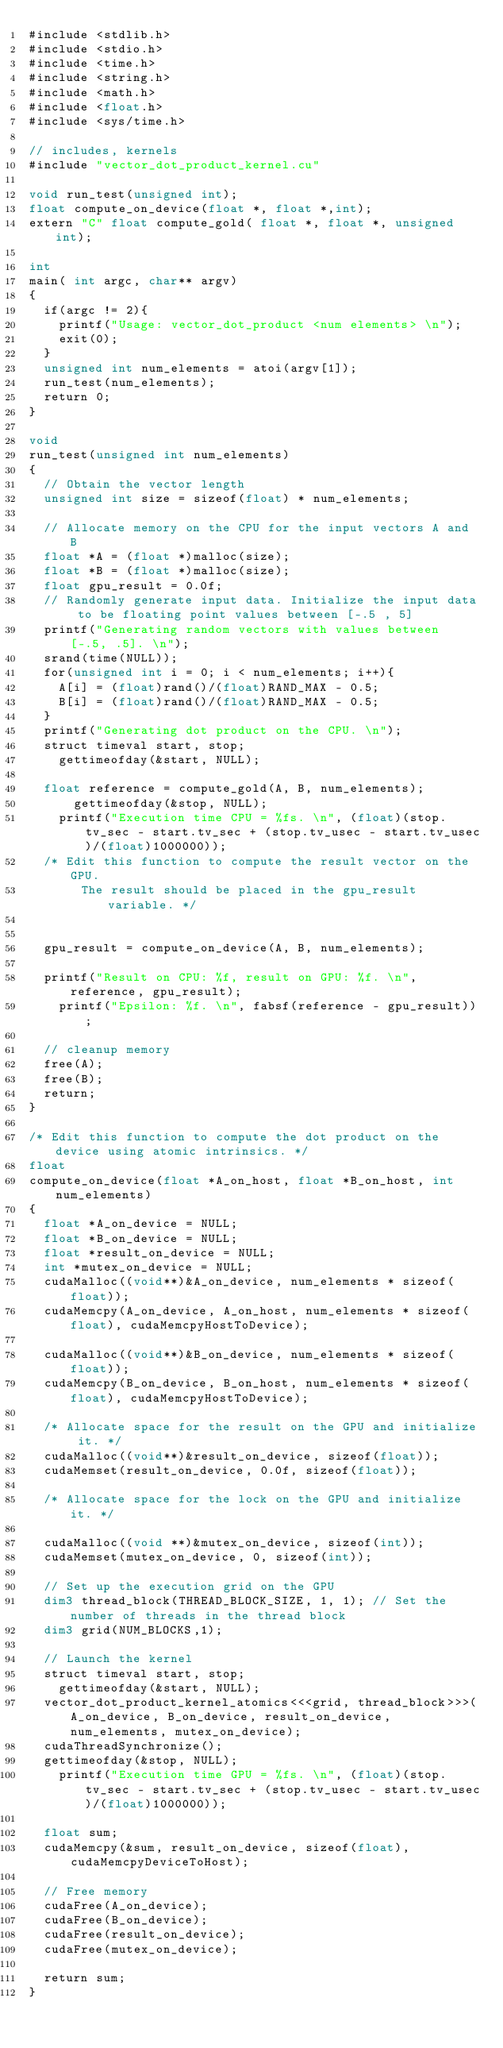Convert code to text. <code><loc_0><loc_0><loc_500><loc_500><_Cuda_>#include <stdlib.h>
#include <stdio.h>
#include <time.h>
#include <string.h>
#include <math.h>
#include <float.h>
#include <sys/time.h>

// includes, kernels
#include "vector_dot_product_kernel.cu"

void run_test(unsigned int);
float compute_on_device(float *, float *,int);
extern "C" float compute_gold( float *, float *, unsigned int);

int 
main( int argc, char** argv) 
{
	if(argc != 2){
		printf("Usage: vector_dot_product <num elements> \n");
		exit(0);	
	}
	unsigned int num_elements = atoi(argv[1]);
	run_test(num_elements);
	return 0;
}

void 
run_test(unsigned int num_elements) 
{
	// Obtain the vector length
	unsigned int size = sizeof(float) * num_elements;

	// Allocate memory on the CPU for the input vectors A and B
	float *A = (float *)malloc(size);
	float *B = (float *)malloc(size);
	float gpu_result = 0.0f;
	// Randomly generate input data. Initialize the input data to be floating point values between [-.5 , 5]
	printf("Generating random vectors with values between [-.5, .5]. \n");	
	srand(time(NULL));
	for(unsigned int i = 0; i < num_elements; i++){
		A[i] = (float)rand()/(float)RAND_MAX - 0.5;
		B[i] = (float)rand()/(float)RAND_MAX - 0.5;
	}
	printf("Generating dot product on the CPU. \n");
	struct timeval start, stop;	
		gettimeofday(&start, NULL);	

	float reference = compute_gold(A, B, num_elements);
    	gettimeofday(&stop, NULL);
		printf("Execution time CPU = %fs. \n", (float)(stop.tv_sec - start.tv_sec + (stop.tv_usec - start.tv_usec)/(float)1000000));
	/* Edit this function to compute the result vector on the GPU. 
       The result should be placed in the gpu_result variable. */
	

	gpu_result = compute_on_device(A, B, num_elements);

	printf("Result on CPU: %f, result on GPU: %f. \n", reference, gpu_result);
    printf("Epsilon: %f. \n", fabsf(reference - gpu_result));

	// cleanup memory
	free(A);
	free(B);
	return;
}

/* Edit this function to compute the dot product on the device using atomic intrinsics. */
float
compute_on_device(float *A_on_host, float *B_on_host, int num_elements)
{
	float *A_on_device = NULL;
	float *B_on_device = NULL;
	float *result_on_device = NULL;
	int *mutex_on_device = NULL;	
	cudaMalloc((void**)&A_on_device, num_elements * sizeof(float));
	cudaMemcpy(A_on_device, A_on_host, num_elements * sizeof(float), cudaMemcpyHostToDevice);

	cudaMalloc((void**)&B_on_device, num_elements * sizeof(float));
	cudaMemcpy(B_on_device, B_on_host, num_elements * sizeof(float), cudaMemcpyHostToDevice);
	
	/* Allocate space for the result on the GPU and initialize it. */
	cudaMalloc((void**)&result_on_device, sizeof(float));
	cudaMemset(result_on_device, 0.0f, sizeof(float));

	/* Allocate space for the lock on the GPU and initialize it. */

	cudaMalloc((void **)&mutex_on_device, sizeof(int));
	cudaMemset(mutex_on_device, 0, sizeof(int));
	
	// Set up the execution grid on the GPU
	dim3 thread_block(THREAD_BLOCK_SIZE, 1, 1); // Set the number of threads in the thread block
	dim3 grid(NUM_BLOCKS,1);
	
	// Launch the kernel
	struct timeval start, stop;	
		gettimeofday(&start, NULL);	
	vector_dot_product_kernel_atomics<<<grid, thread_block>>>(A_on_device, B_on_device, result_on_device, num_elements, mutex_on_device);
	cudaThreadSynchronize();
	gettimeofday(&stop, NULL);
		printf("Execution time GPU = %fs. \n", (float)(stop.tv_sec - start.tv_sec + (stop.tv_usec - start.tv_usec)/(float)1000000));

	float sum;
	cudaMemcpy(&sum, result_on_device, sizeof(float), cudaMemcpyDeviceToHost);
	
	// Free memory
	cudaFree(A_on_device);
	cudaFree(B_on_device);
	cudaFree(result_on_device);
	cudaFree(mutex_on_device);
	
	return sum;
}
 

</code> 